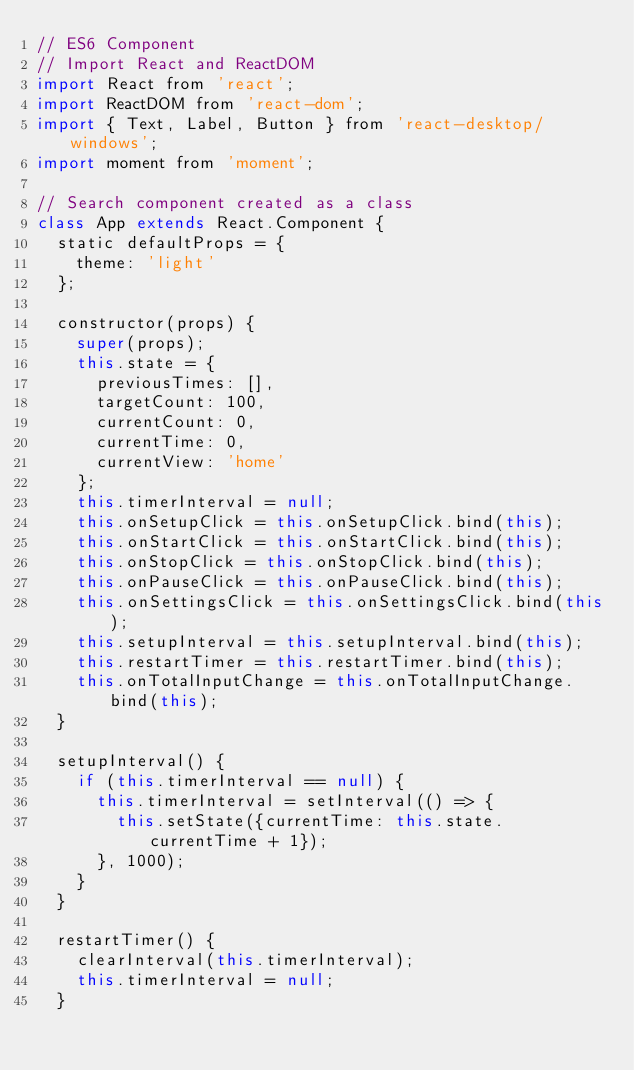Convert code to text. <code><loc_0><loc_0><loc_500><loc_500><_JavaScript_>// ES6 Component
// Import React and ReactDOM
import React from 'react';
import ReactDOM from 'react-dom';
import { Text, Label, Button } from 'react-desktop/windows';
import moment from 'moment';

// Search component created as a class
class App extends React.Component {
  static defaultProps = {
    theme: 'light'
  };

  constructor(props) {
    super(props);
    this.state = {
      previousTimes: [],
      targetCount: 100,
      currentCount: 0,
      currentTime: 0,
      currentView: 'home'
    };
    this.timerInterval = null;
    this.onSetupClick = this.onSetupClick.bind(this);
    this.onStartClick = this.onStartClick.bind(this);
    this.onStopClick = this.onStopClick.bind(this);
    this.onPauseClick = this.onPauseClick.bind(this);
    this.onSettingsClick = this.onSettingsClick.bind(this);
    this.setupInterval = this.setupInterval.bind(this);
    this.restartTimer = this.restartTimer.bind(this);
    this.onTotalInputChange = this.onTotalInputChange.bind(this);
  }

  setupInterval() {
    if (this.timerInterval == null) {
      this.timerInterval = setInterval(() => {
        this.setState({currentTime: this.state.currentTime + 1});
      }, 1000);
    }
  }

  restartTimer() {
    clearInterval(this.timerInterval);
    this.timerInterval = null;
  }
</code> 